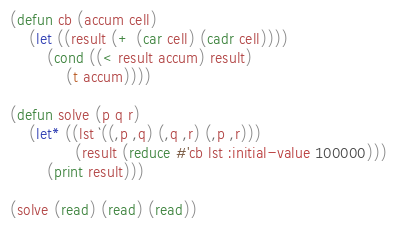Convert code to text. <code><loc_0><loc_0><loc_500><loc_500><_Lisp_>(defun cb (accum cell)
    (let ((result (+ (car cell) (cadr cell))))
        (cond ((< result accum) result)
            (t accum))))

(defun solve (p q r)
    (let* ((lst `((,p ,q) (,q ,r) (,p ,r)))
              (result (reduce #'cb lst :initial-value 100000)))
        (print result)))

(solve (read) (read) (read))
</code> 